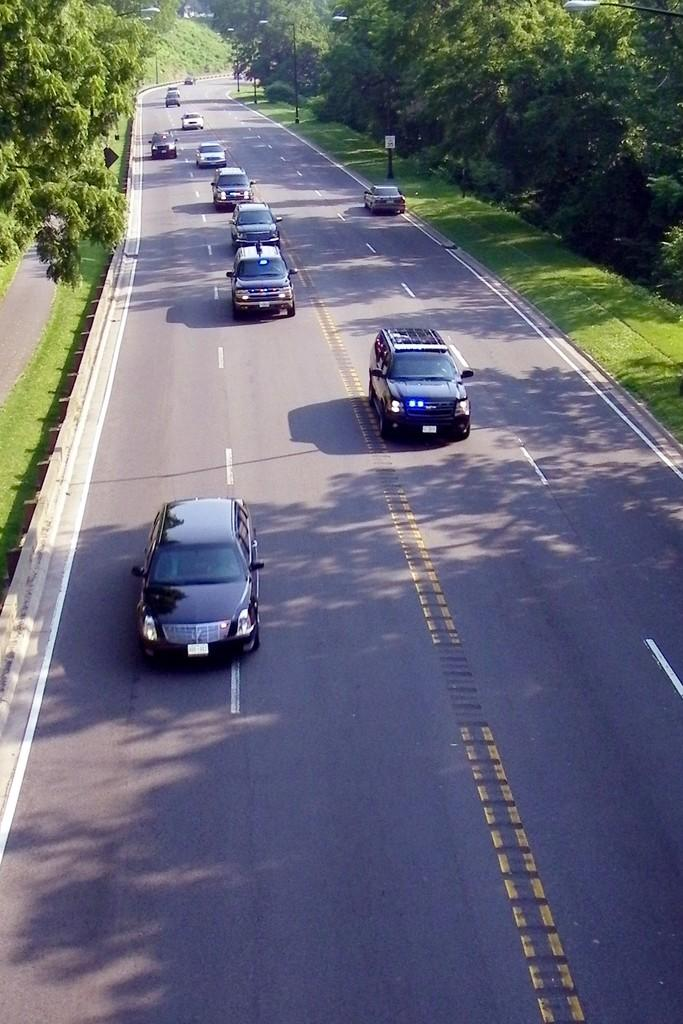What is at the bottom of the image? There is a road at the bottom of the image. What is on the road? There are cars on the road. What type of vegetation can be seen on the right side of the image? There are trees on the right side of the image. What type of vegetation can be seen on the left side of the image? There are trees on the left side of the image. What type of ground cover is visible in the image? There is grass visible in the image. What structures can be seen in the image? There are poles present in the image. Can you see the face of the parent in the image? There is no face or parent present in the image. What is the slope of the road in the image? The image does not provide information about the slope of the road; it only shows the road at the bottom of the image. 